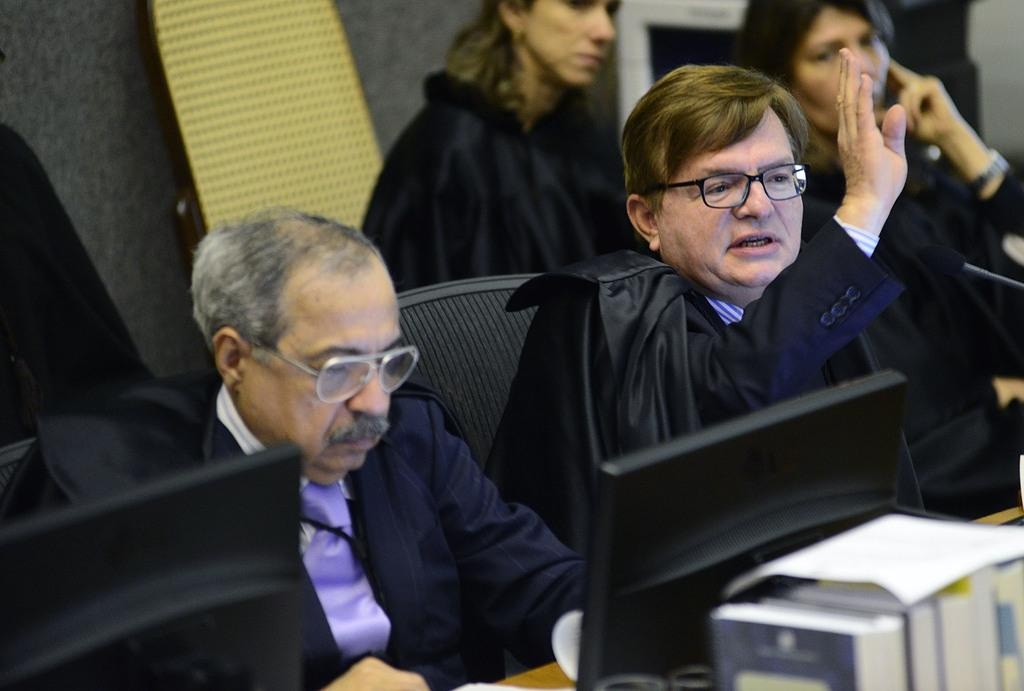What are the people in the image doing? The persons sitting in the image are likely engaged in some activity or conversation. What color are the coats worn by the persons in the image? The persons are wearing black color coats. Can you describe the objects visible in the foreground of the image? There are systems visible in the foreground of the image. Are there any cherries being used as a prop in the image? There is no mention of cherries or any props in the image. What type of chalk is being used by the persons in the image? There is no chalk or any indication of writing or drawing in the image. 